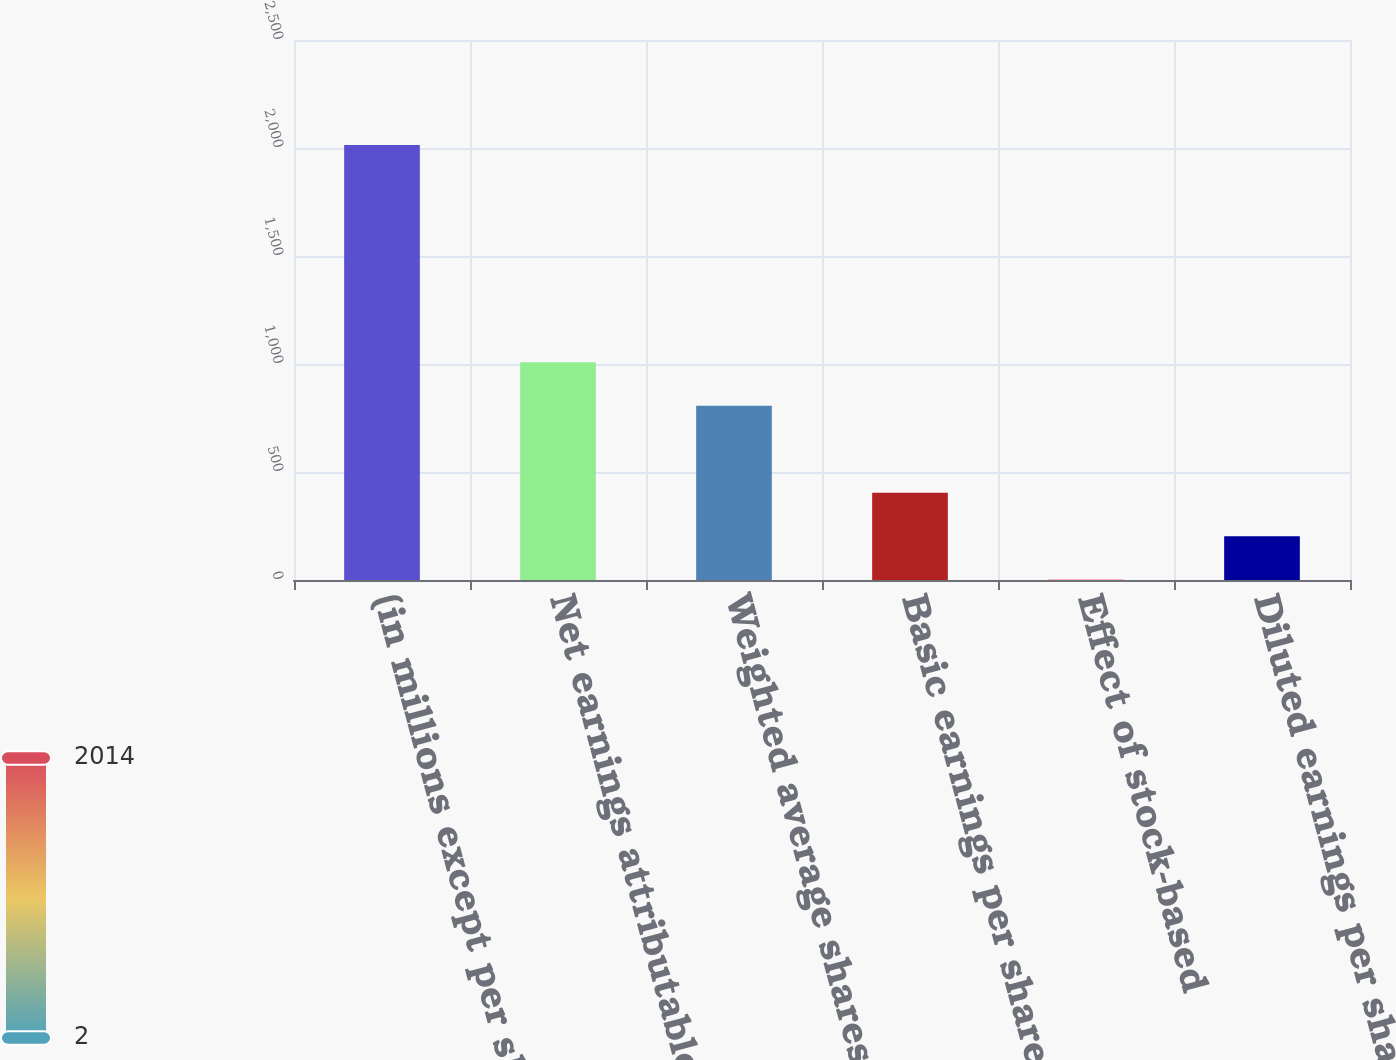Convert chart. <chart><loc_0><loc_0><loc_500><loc_500><bar_chart><fcel>(in millions except per share<fcel>Net earnings attributable to<fcel>Weighted average shares of<fcel>Basic earnings per share of<fcel>Effect of stock-based<fcel>Diluted earnings per share of<nl><fcel>2014<fcel>1007.87<fcel>806.65<fcel>404.21<fcel>1.77<fcel>202.99<nl></chart> 